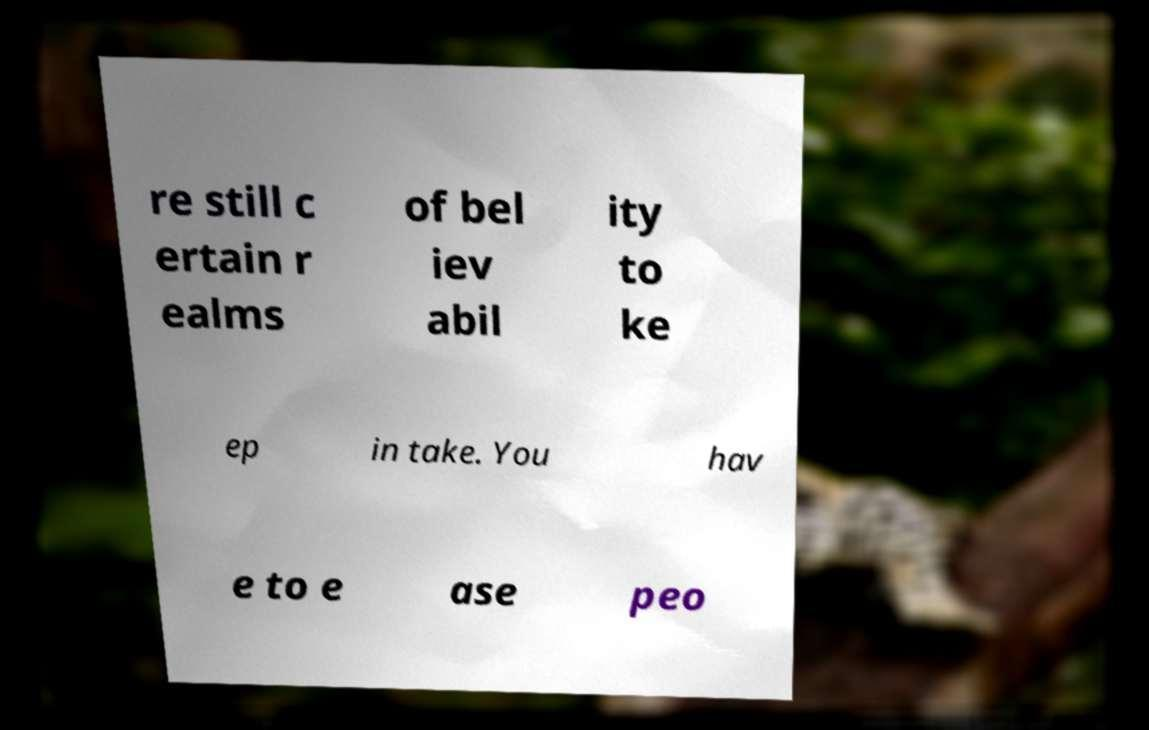Could you extract and type out the text from this image? re still c ertain r ealms of bel iev abil ity to ke ep in take. You hav e to e ase peo 